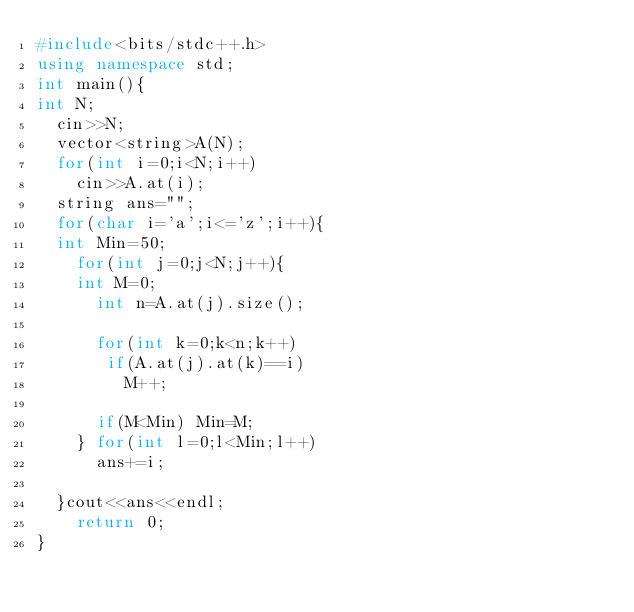<code> <loc_0><loc_0><loc_500><loc_500><_C++_>#include<bits/stdc++.h>
using namespace std;
int main(){
int N;
  cin>>N;
  vector<string>A(N);
  for(int i=0;i<N;i++)
    cin>>A.at(i);
  string ans="";
  for(char i='a';i<='z';i++){
  int Min=50;
    for(int j=0;j<N;j++){
    int M=0;
      int n=A.at(j).size();
       
      for(int k=0;k<n;k++)
       if(A.at(j).at(k)==i)
         M++;
      
      if(M<Min) Min=M;
    } for(int l=0;l<Min;l++)
      ans+=i;
  
  }cout<<ans<<endl;
    return 0;
}</code> 